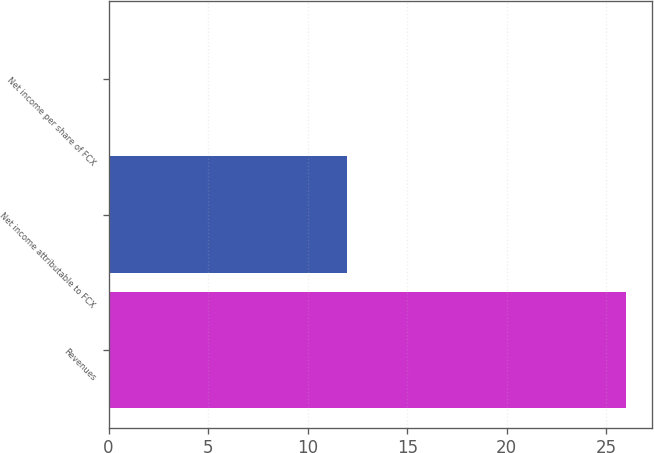<chart> <loc_0><loc_0><loc_500><loc_500><bar_chart><fcel>Revenues<fcel>Net income attributable to FCX<fcel>Net income per share of FCX<nl><fcel>26<fcel>12<fcel>0.01<nl></chart> 